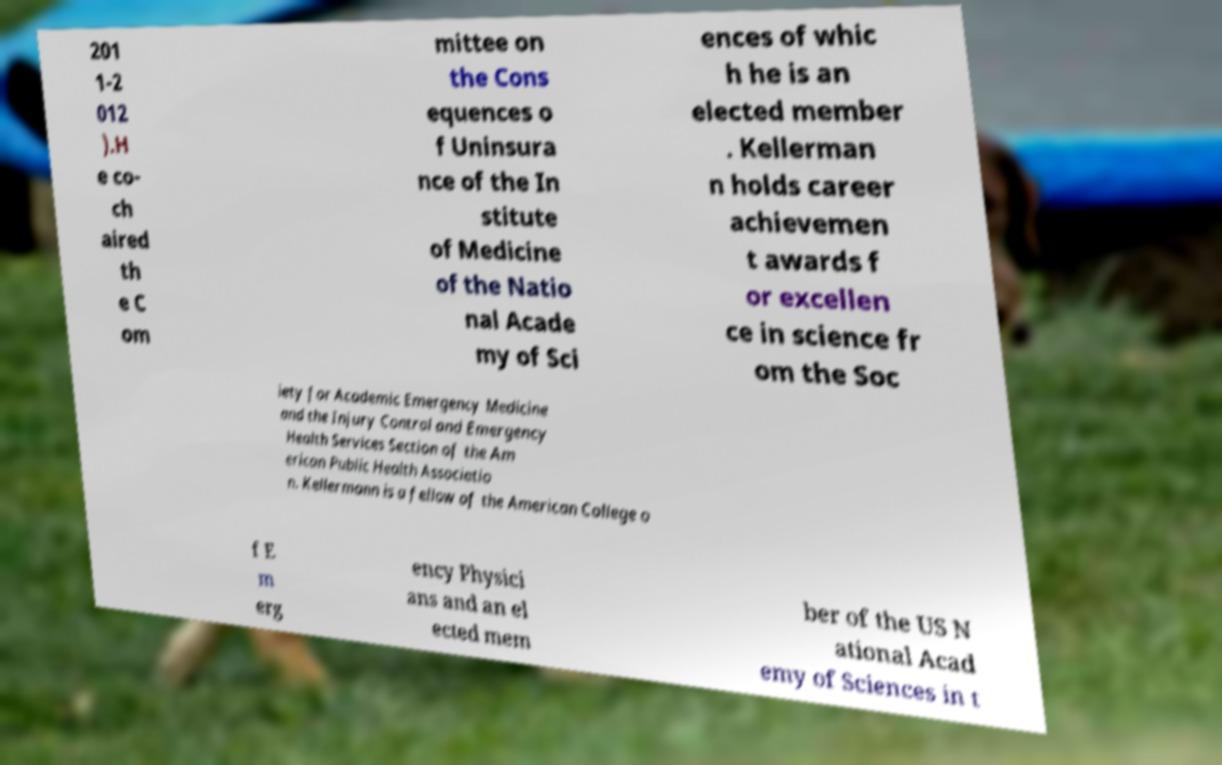For documentation purposes, I need the text within this image transcribed. Could you provide that? 201 1-2 012 ).H e co- ch aired th e C om mittee on the Cons equences o f Uninsura nce of the In stitute of Medicine of the Natio nal Acade my of Sci ences of whic h he is an elected member . Kellerman n holds career achievemen t awards f or excellen ce in science fr om the Soc iety for Academic Emergency Medicine and the Injury Control and Emergency Health Services Section of the Am erican Public Health Associatio n. Kellermann is a fellow of the American College o f E m erg ency Physici ans and an el ected mem ber of the US N ational Acad emy of Sciences in t 